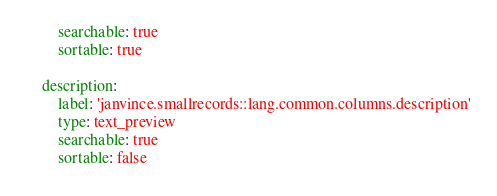<code> <loc_0><loc_0><loc_500><loc_500><_YAML_>        searchable: true
        sortable: true

    description:
        label: 'janvince.smallrecords::lang.common.columns.description'
        type: text_preview
        searchable: true
        sortable: false
</code> 